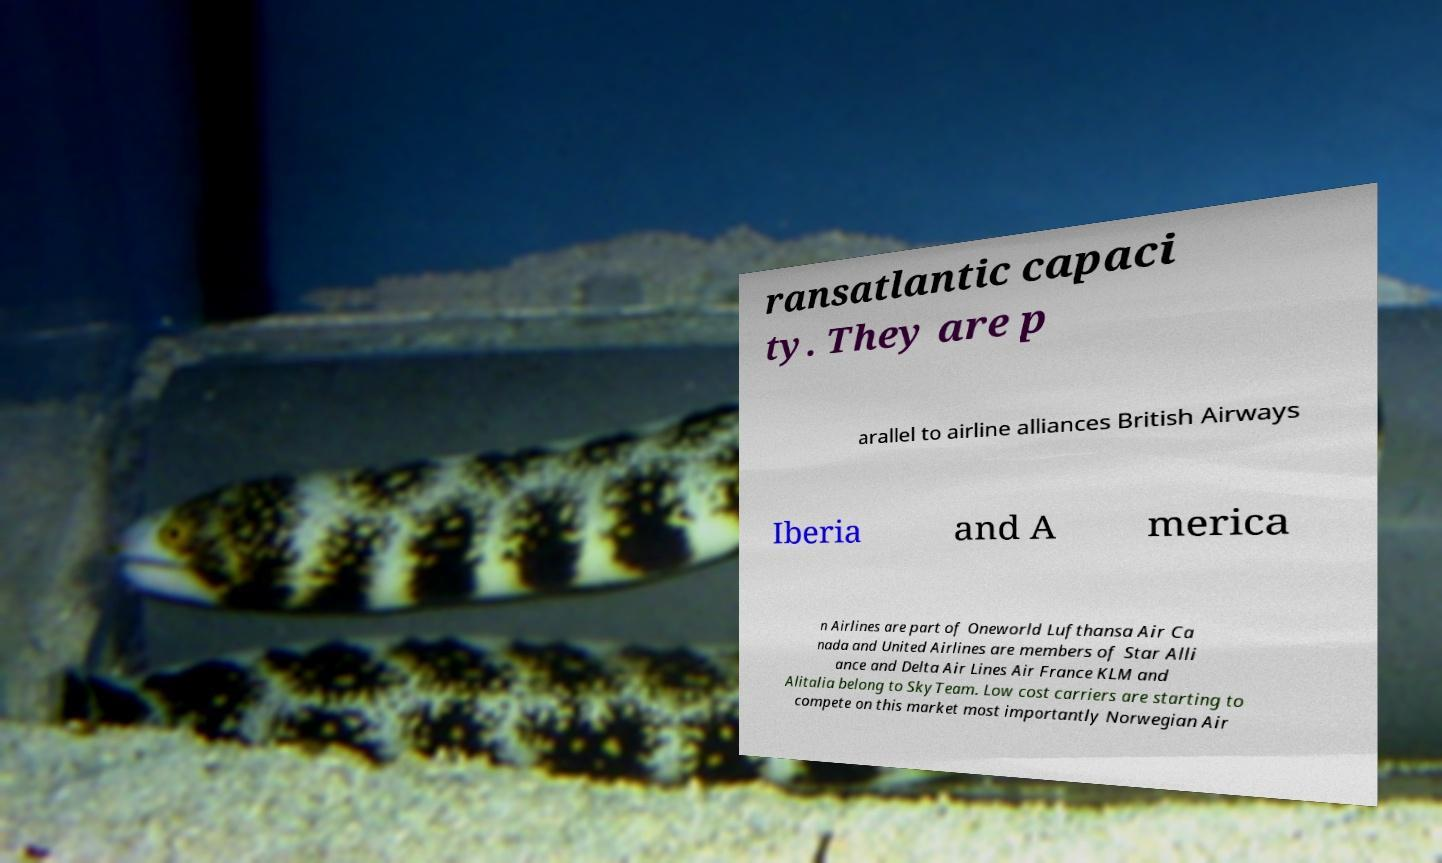Can you accurately transcribe the text from the provided image for me? ransatlantic capaci ty. They are p arallel to airline alliances British Airways Iberia and A merica n Airlines are part of Oneworld Lufthansa Air Ca nada and United Airlines are members of Star Alli ance and Delta Air Lines Air France KLM and Alitalia belong to SkyTeam. Low cost carriers are starting to compete on this market most importantly Norwegian Air 